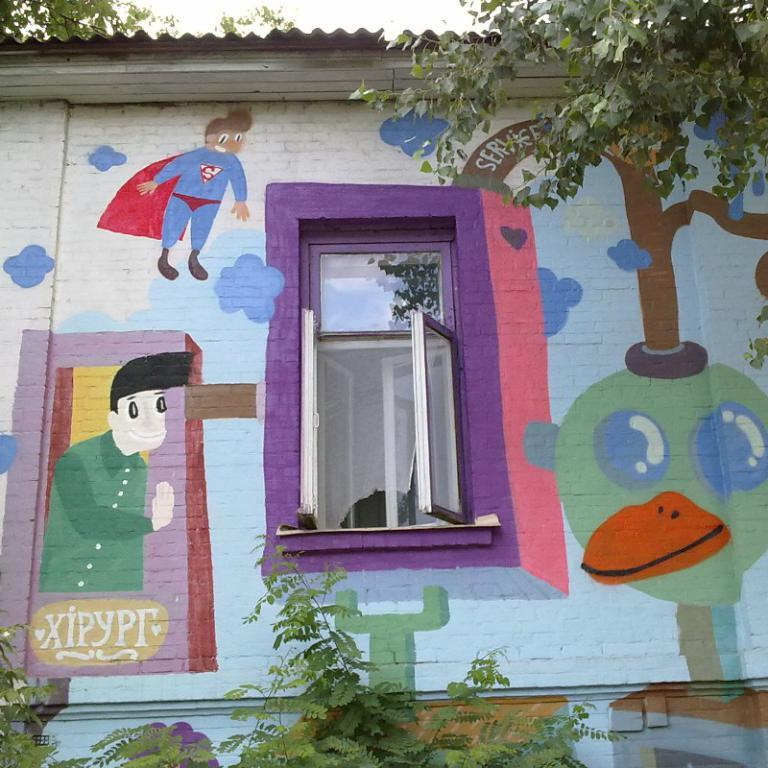What type of artwork is present on the wall in the image? There are cartoon paintings on the wall in the image. What is located at the center of the wall? There is a glass window at the center of the wall. What can be seen at the bottom of the image? Trees are visible at the bottom of the image. What type of zinc is used to make the soup in the image? There is no soup present in the image, so the type of zinc used cannot be determined. What is the wax used for in the image? There is no wax present in the image, so its purpose cannot be determined. 